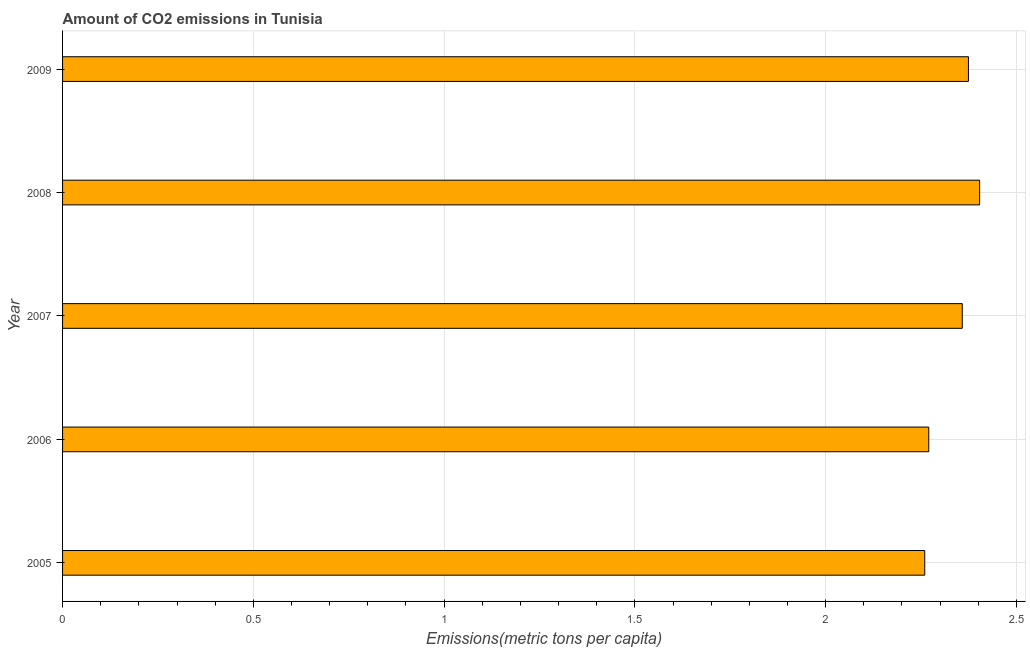What is the title of the graph?
Provide a short and direct response. Amount of CO2 emissions in Tunisia. What is the label or title of the X-axis?
Offer a very short reply. Emissions(metric tons per capita). What is the amount of co2 emissions in 2006?
Make the answer very short. 2.27. Across all years, what is the maximum amount of co2 emissions?
Make the answer very short. 2.4. Across all years, what is the minimum amount of co2 emissions?
Your answer should be very brief. 2.26. In which year was the amount of co2 emissions maximum?
Provide a succinct answer. 2008. What is the sum of the amount of co2 emissions?
Provide a short and direct response. 11.67. What is the difference between the amount of co2 emissions in 2008 and 2009?
Provide a succinct answer. 0.03. What is the average amount of co2 emissions per year?
Provide a short and direct response. 2.33. What is the median amount of co2 emissions?
Your response must be concise. 2.36. Do a majority of the years between 2006 and 2007 (inclusive) have amount of co2 emissions greater than 0.3 metric tons per capita?
Your answer should be very brief. Yes. What is the difference between the highest and the second highest amount of co2 emissions?
Your response must be concise. 0.03. What is the difference between the highest and the lowest amount of co2 emissions?
Offer a very short reply. 0.14. In how many years, is the amount of co2 emissions greater than the average amount of co2 emissions taken over all years?
Make the answer very short. 3. Are all the bars in the graph horizontal?
Offer a terse response. Yes. How many years are there in the graph?
Ensure brevity in your answer.  5. What is the difference between two consecutive major ticks on the X-axis?
Your answer should be compact. 0.5. Are the values on the major ticks of X-axis written in scientific E-notation?
Ensure brevity in your answer.  No. What is the Emissions(metric tons per capita) in 2005?
Your answer should be very brief. 2.26. What is the Emissions(metric tons per capita) in 2006?
Provide a succinct answer. 2.27. What is the Emissions(metric tons per capita) in 2007?
Your answer should be compact. 2.36. What is the Emissions(metric tons per capita) in 2008?
Offer a very short reply. 2.4. What is the Emissions(metric tons per capita) of 2009?
Keep it short and to the point. 2.37. What is the difference between the Emissions(metric tons per capita) in 2005 and 2006?
Ensure brevity in your answer.  -0.01. What is the difference between the Emissions(metric tons per capita) in 2005 and 2007?
Your response must be concise. -0.1. What is the difference between the Emissions(metric tons per capita) in 2005 and 2008?
Give a very brief answer. -0.14. What is the difference between the Emissions(metric tons per capita) in 2005 and 2009?
Keep it short and to the point. -0.11. What is the difference between the Emissions(metric tons per capita) in 2006 and 2007?
Offer a terse response. -0.09. What is the difference between the Emissions(metric tons per capita) in 2006 and 2008?
Give a very brief answer. -0.13. What is the difference between the Emissions(metric tons per capita) in 2006 and 2009?
Make the answer very short. -0.1. What is the difference between the Emissions(metric tons per capita) in 2007 and 2008?
Provide a short and direct response. -0.05. What is the difference between the Emissions(metric tons per capita) in 2007 and 2009?
Offer a very short reply. -0.02. What is the difference between the Emissions(metric tons per capita) in 2008 and 2009?
Keep it short and to the point. 0.03. What is the ratio of the Emissions(metric tons per capita) in 2005 to that in 2006?
Make the answer very short. 0.99. What is the ratio of the Emissions(metric tons per capita) in 2005 to that in 2007?
Keep it short and to the point. 0.96. What is the ratio of the Emissions(metric tons per capita) in 2005 to that in 2009?
Provide a succinct answer. 0.95. What is the ratio of the Emissions(metric tons per capita) in 2006 to that in 2007?
Keep it short and to the point. 0.96. What is the ratio of the Emissions(metric tons per capita) in 2006 to that in 2008?
Your answer should be very brief. 0.94. What is the ratio of the Emissions(metric tons per capita) in 2006 to that in 2009?
Keep it short and to the point. 0.96. What is the ratio of the Emissions(metric tons per capita) in 2007 to that in 2008?
Your answer should be compact. 0.98. 